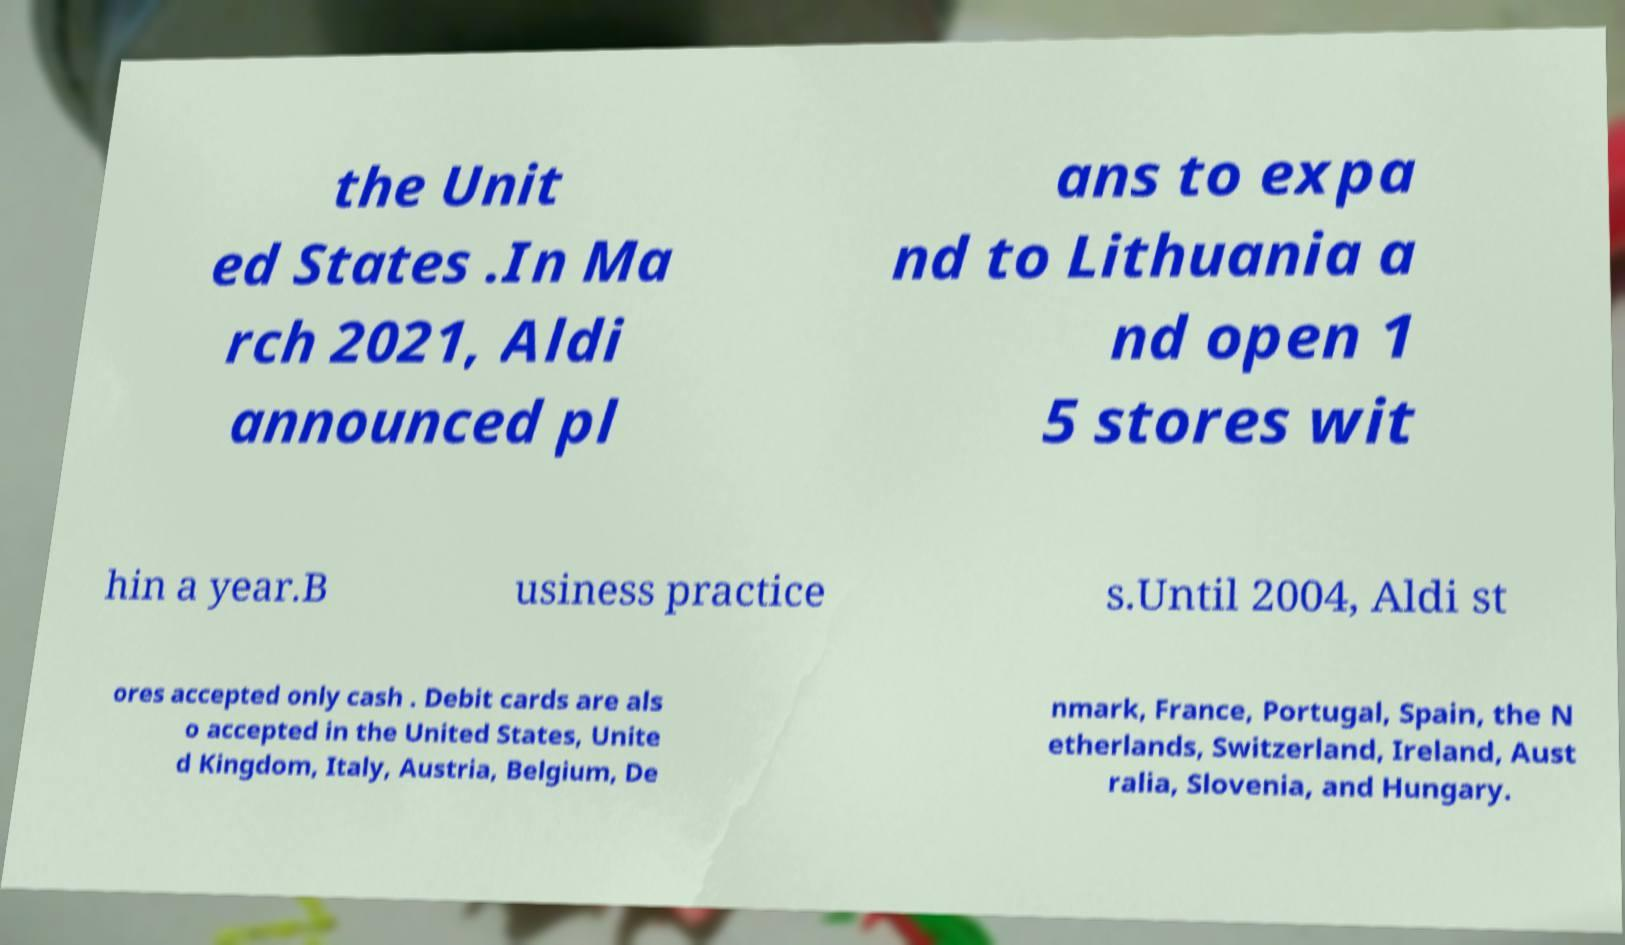Could you assist in decoding the text presented in this image and type it out clearly? the Unit ed States .In Ma rch 2021, Aldi announced pl ans to expa nd to Lithuania a nd open 1 5 stores wit hin a year.B usiness practice s.Until 2004, Aldi st ores accepted only cash . Debit cards are als o accepted in the United States, Unite d Kingdom, Italy, Austria, Belgium, De nmark, France, Portugal, Spain, the N etherlands, Switzerland, Ireland, Aust ralia, Slovenia, and Hungary. 